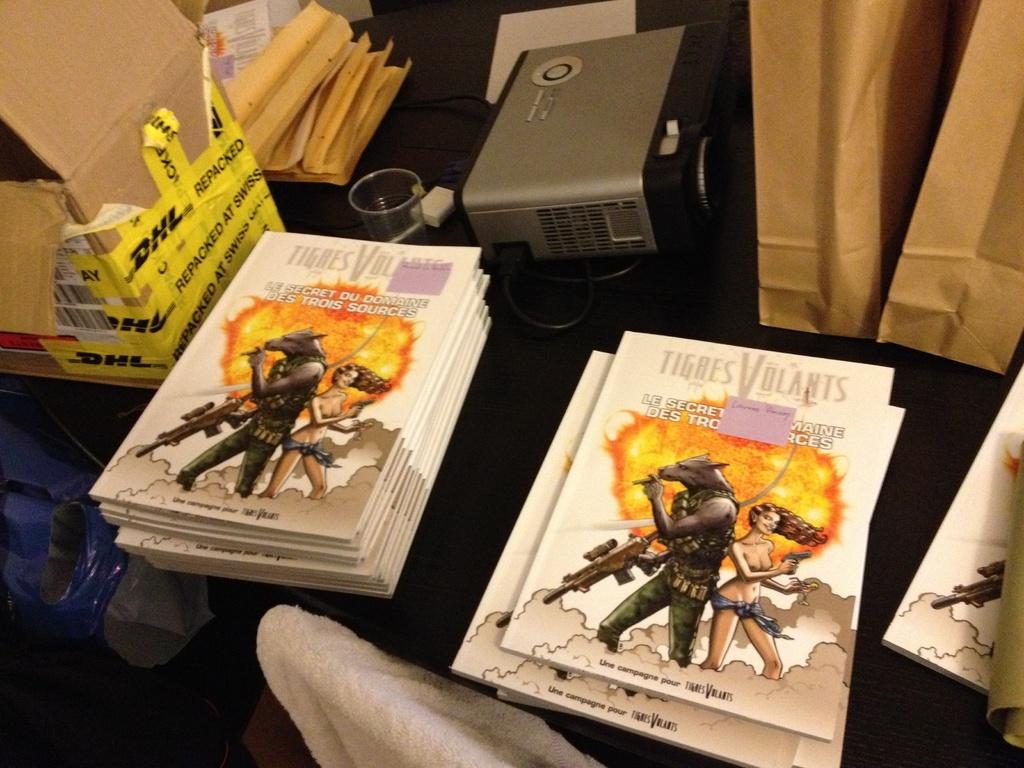What is the title of the book?
Give a very brief answer. Tigres volants. What company shipped the box on the left?
Your answer should be compact. Dhl. 